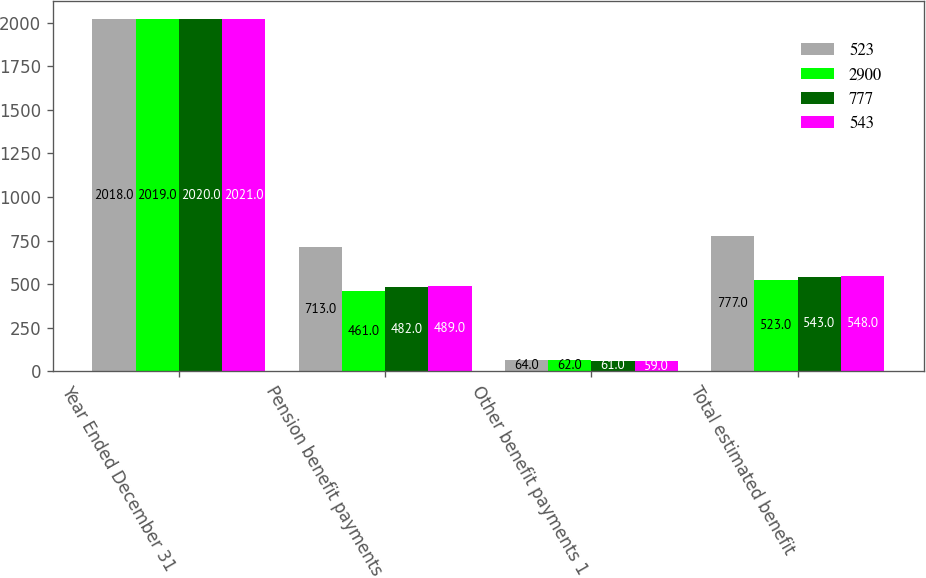<chart> <loc_0><loc_0><loc_500><loc_500><stacked_bar_chart><ecel><fcel>Year Ended December 31<fcel>Pension benefit payments<fcel>Other benefit payments 1<fcel>Total estimated benefit<nl><fcel>523<fcel>2018<fcel>713<fcel>64<fcel>777<nl><fcel>2900<fcel>2019<fcel>461<fcel>62<fcel>523<nl><fcel>777<fcel>2020<fcel>482<fcel>61<fcel>543<nl><fcel>543<fcel>2021<fcel>489<fcel>59<fcel>548<nl></chart> 